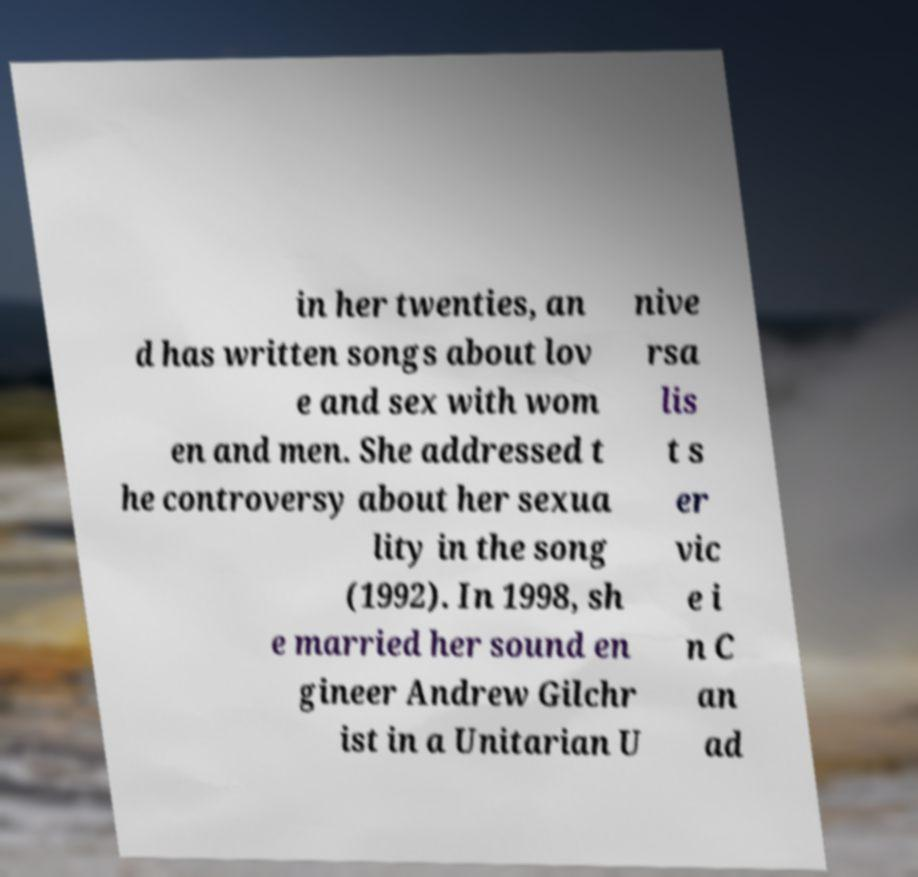For documentation purposes, I need the text within this image transcribed. Could you provide that? in her twenties, an d has written songs about lov e and sex with wom en and men. She addressed t he controversy about her sexua lity in the song (1992). In 1998, sh e married her sound en gineer Andrew Gilchr ist in a Unitarian U nive rsa lis t s er vic e i n C an ad 